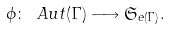Convert formula to latex. <formula><loc_0><loc_0><loc_500><loc_500>\phi \colon \ A u t ( \Gamma ) \longrightarrow \mathfrak { S } _ { e ( \Gamma ) } .</formula> 